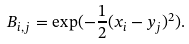<formula> <loc_0><loc_0><loc_500><loc_500>B _ { i , j } = \exp ( - \frac { 1 } { 2 } ( x _ { i } - y _ { j } ) ^ { 2 } ) .</formula> 